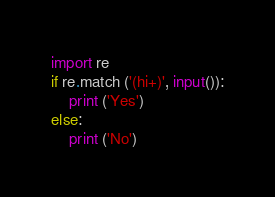Convert code to text. <code><loc_0><loc_0><loc_500><loc_500><_Python_>import re
if re.match ('(hi+)', input()):
    print ('Yes')
else:
    print ('No')</code> 